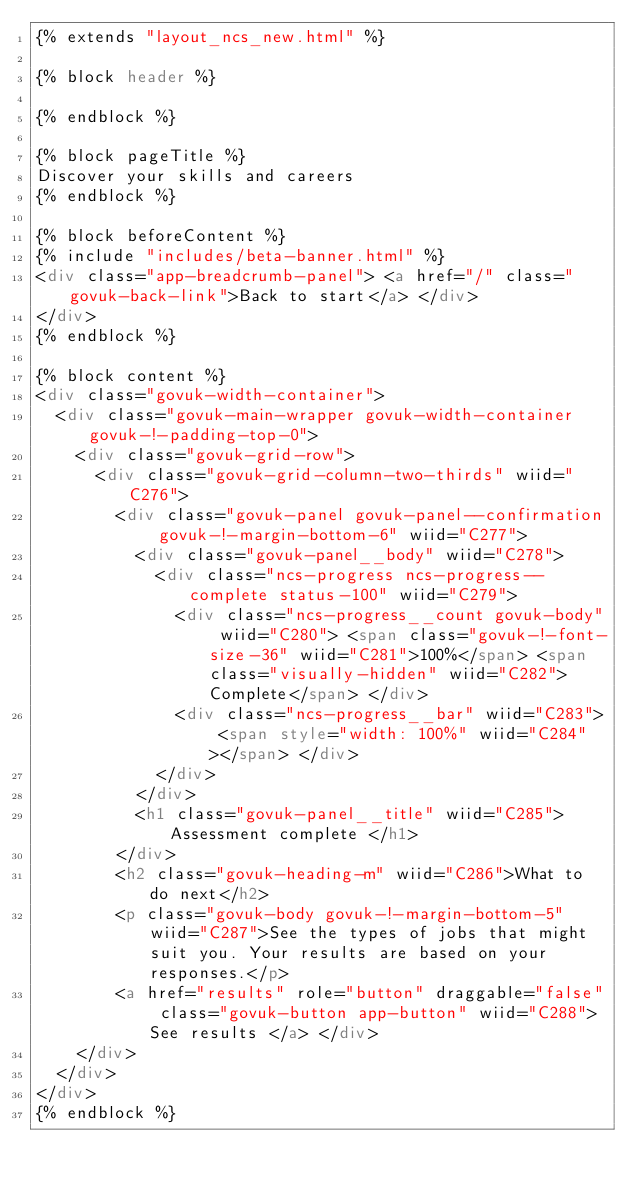Convert code to text. <code><loc_0><loc_0><loc_500><loc_500><_HTML_>{% extends "layout_ncs_new.html" %}

{% block header %}

{% endblock %}

{% block pageTitle %}
Discover your skills and careers
{% endblock %}

{% block beforeContent %}
{% include "includes/beta-banner.html" %}
<div class="app-breadcrumb-panel"> <a href="/" class="govuk-back-link">Back to start</a> </div>
</div>
{% endblock %}

{% block content %}
<div class="govuk-width-container">
  <div class="govuk-main-wrapper govuk-width-container  govuk-!-padding-top-0">
    <div class="govuk-grid-row">
      <div class="govuk-grid-column-two-thirds" wiid="C276">
        <div class="govuk-panel govuk-panel--confirmation govuk-!-margin-bottom-6" wiid="C277">
          <div class="govuk-panel__body" wiid="C278">
            <div class="ncs-progress ncs-progress--complete status-100" wiid="C279">
              <div class="ncs-progress__count govuk-body" wiid="C280"> <span class="govuk-!-font-size-36" wiid="C281">100%</span> <span class="visually-hidden" wiid="C282">Complete</span> </div>
              <div class="ncs-progress__bar" wiid="C283"> <span style="width: 100%" wiid="C284"></span> </div>
            </div>
          </div>
          <h1 class="govuk-panel__title" wiid="C285"> Assessment complete </h1>
        </div>
        <h2 class="govuk-heading-m" wiid="C286">What to do next</h2>
        <p class="govuk-body govuk-!-margin-bottom-5" wiid="C287">See the types of jobs that might suit you. Your results are based on your responses.</p>
        <a href="results" role="button" draggable="false" class="govuk-button app-button" wiid="C288"> See results </a> </div>
    </div>
  </div>
</div>
{% endblock %} </code> 